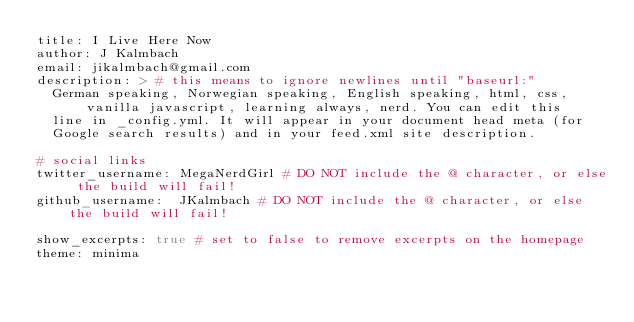<code> <loc_0><loc_0><loc_500><loc_500><_YAML_>title: I Live Here Now
author: J Kalmbach
email: jikalmbach@gmail.com
description: > # this means to ignore newlines until "baseurl:"
  German speaking, Norwegian speaking, English speaking, html, css, vanilla javascript, learning always, nerd. You can edit this
  line in _config.yml. It will appear in your document head meta (for
  Google search results) and in your feed.xml site description.

# social links
twitter_username: MegaNerdGirl # DO NOT include the @ character, or else the build will fail!
github_username:  JKalmbach # DO NOT include the @ character, or else the build will fail!

show_excerpts: true # set to false to remove excerpts on the homepage
theme: minima
</code> 